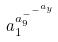<formula> <loc_0><loc_0><loc_500><loc_500>a _ { 1 } ^ { a _ { 9 } ^ { - ^ { - ^ { a _ { y } } } } }</formula> 